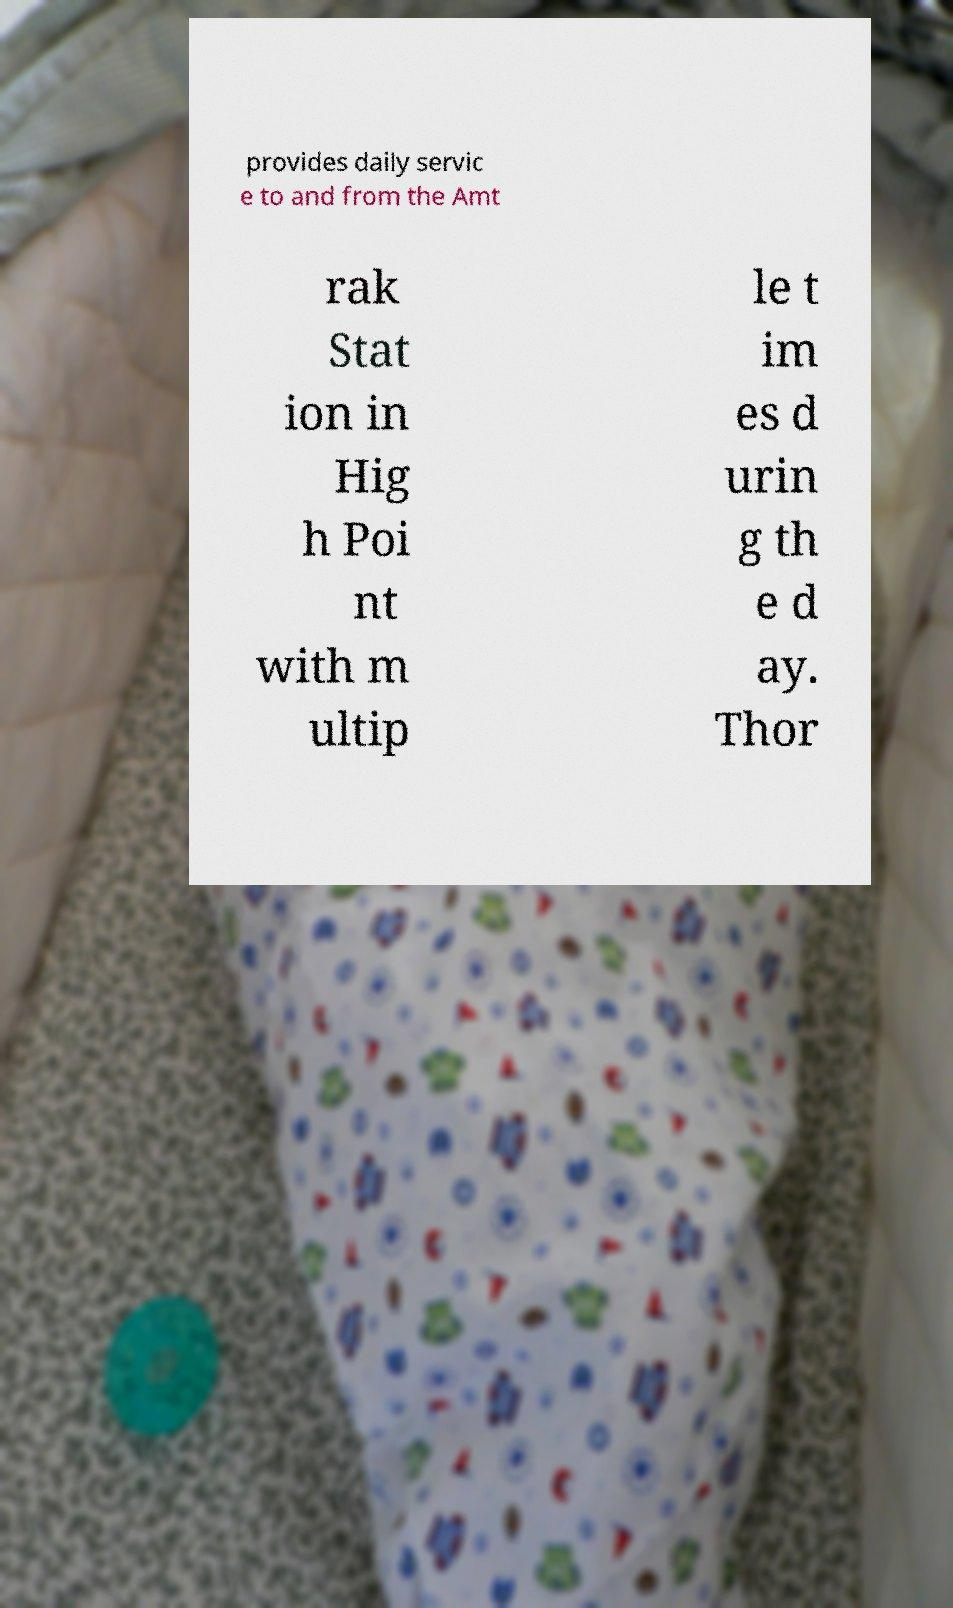For documentation purposes, I need the text within this image transcribed. Could you provide that? provides daily servic e to and from the Amt rak Stat ion in Hig h Poi nt with m ultip le t im es d urin g th e d ay. Thor 